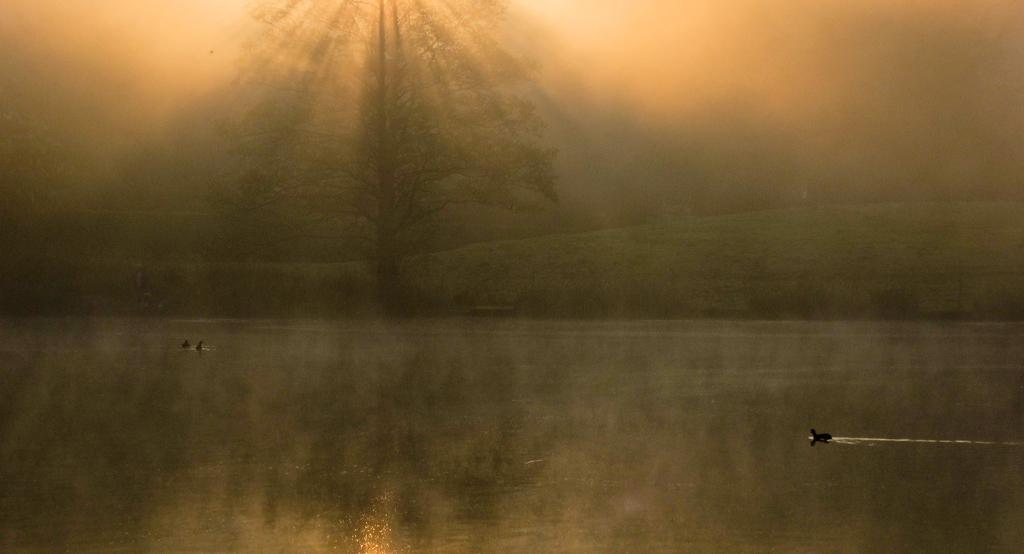What is the main element in the image? There is water in the image. What can be seen on the surface of the water? There are animals on the surface of the water. What type of vegetation is visible in the image? There is grass visible in the image. What other natural element is present in the image? There is a tree in the image. What is the color of the sky in the background? The sky in the background is orange in color. What type of church can be seen in the image? There is no church present in the image. What does the tongue of the animal on the water look like? There is no tongue visible in the image, as the animals are not shown in a way that would reveal their tongues. 